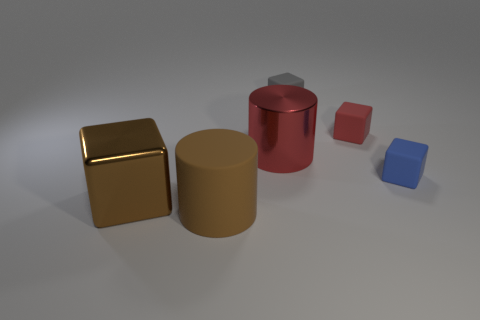Subtract 1 cubes. How many cubes are left? 3 Subtract all gray blocks. Subtract all purple cylinders. How many blocks are left? 3 Add 4 large blue rubber objects. How many objects exist? 10 Subtract all cubes. How many objects are left? 2 Subtract 0 cyan cubes. How many objects are left? 6 Subtract all yellow matte cylinders. Subtract all large brown cylinders. How many objects are left? 5 Add 1 brown rubber things. How many brown rubber things are left? 2 Add 2 small red rubber blocks. How many small red rubber blocks exist? 3 